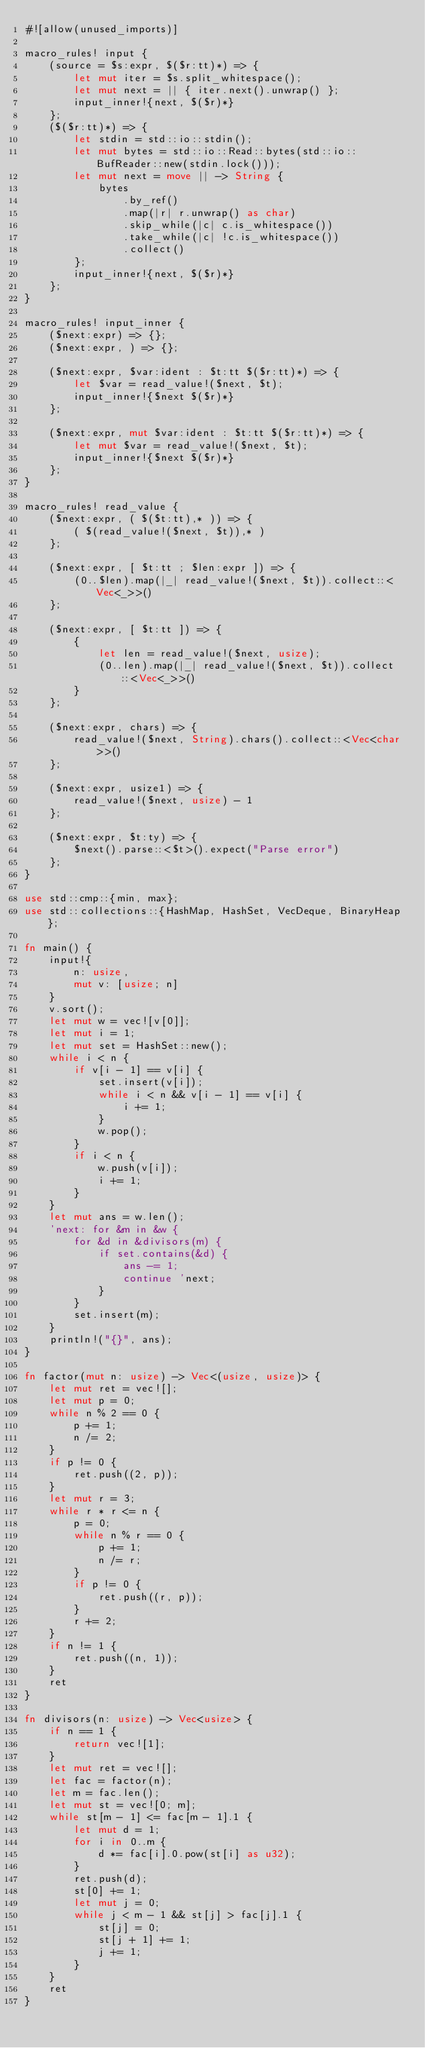<code> <loc_0><loc_0><loc_500><loc_500><_Rust_>#![allow(unused_imports)]

macro_rules! input {
    (source = $s:expr, $($r:tt)*) => {
        let mut iter = $s.split_whitespace();
        let mut next = || { iter.next().unwrap() };
        input_inner!{next, $($r)*}
    };
    ($($r:tt)*) => {
        let stdin = std::io::stdin();
        let mut bytes = std::io::Read::bytes(std::io::BufReader::new(stdin.lock()));
        let mut next = move || -> String {
            bytes
                .by_ref()
                .map(|r| r.unwrap() as char)
                .skip_while(|c| c.is_whitespace())
                .take_while(|c| !c.is_whitespace())
                .collect()
        };
        input_inner!{next, $($r)*}
    };
}

macro_rules! input_inner {
    ($next:expr) => {};
    ($next:expr, ) => {};

    ($next:expr, $var:ident : $t:tt $($r:tt)*) => {
        let $var = read_value!($next, $t);
        input_inner!{$next $($r)*}
    };

    ($next:expr, mut $var:ident : $t:tt $($r:tt)*) => {
        let mut $var = read_value!($next, $t);
        input_inner!{$next $($r)*}
    };
}

macro_rules! read_value {
    ($next:expr, ( $($t:tt),* )) => {
        ( $(read_value!($next, $t)),* )
    };

    ($next:expr, [ $t:tt ; $len:expr ]) => {
        (0..$len).map(|_| read_value!($next, $t)).collect::<Vec<_>>()
    };

    ($next:expr, [ $t:tt ]) => {
        {
            let len = read_value!($next, usize);
            (0..len).map(|_| read_value!($next, $t)).collect::<Vec<_>>()
        }
    };

    ($next:expr, chars) => {
        read_value!($next, String).chars().collect::<Vec<char>>()
    };

    ($next:expr, usize1) => {
        read_value!($next, usize) - 1
    };

    ($next:expr, $t:ty) => {
        $next().parse::<$t>().expect("Parse error")
    };
}

use std::cmp::{min, max};
use std::collections::{HashMap, HashSet, VecDeque, BinaryHeap};

fn main() {
    input!{
        n: usize,
        mut v: [usize; n]
    }
    v.sort();
    let mut w = vec![v[0]];
    let mut i = 1;
    let mut set = HashSet::new();
    while i < n {
        if v[i - 1] == v[i] {
            set.insert(v[i]);
            while i < n && v[i - 1] == v[i] {
                i += 1;
            }
            w.pop();
        }
        if i < n {
            w.push(v[i]);
            i += 1;
        }
    }
    let mut ans = w.len();
    'next: for &m in &w {
        for &d in &divisors(m) {
            if set.contains(&d) {
                ans -= 1;
                continue 'next;
            }
        }
        set.insert(m);
    }
    println!("{}", ans);
}

fn factor(mut n: usize) -> Vec<(usize, usize)> {
    let mut ret = vec![];
    let mut p = 0;
    while n % 2 == 0 {
        p += 1;
        n /= 2;
    }
    if p != 0 {
        ret.push((2, p));
    }
    let mut r = 3;
    while r * r <= n {
        p = 0;
        while n % r == 0 {
            p += 1;
            n /= r;
        }
        if p != 0 {
            ret.push((r, p));
        }
        r += 2;
    }
    if n != 1 {
        ret.push((n, 1));
    }
    ret
}

fn divisors(n: usize) -> Vec<usize> {
    if n == 1 {
        return vec![1];
    }
    let mut ret = vec![];
    let fac = factor(n);
    let m = fac.len();
    let mut st = vec![0; m];
    while st[m - 1] <= fac[m - 1].1 {
        let mut d = 1;
        for i in 0..m {
            d *= fac[i].0.pow(st[i] as u32);
        }
        ret.push(d);
        st[0] += 1;
        let mut j = 0;
        while j < m - 1 && st[j] > fac[j].1 {
            st[j] = 0;
            st[j + 1] += 1;
            j += 1;
        }
    }
    ret
}
</code> 